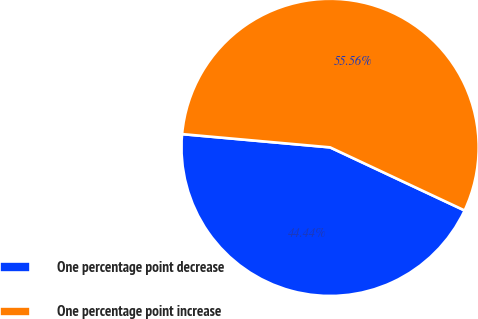Convert chart to OTSL. <chart><loc_0><loc_0><loc_500><loc_500><pie_chart><fcel>One percentage point decrease<fcel>One percentage point increase<nl><fcel>44.44%<fcel>55.56%<nl></chart> 